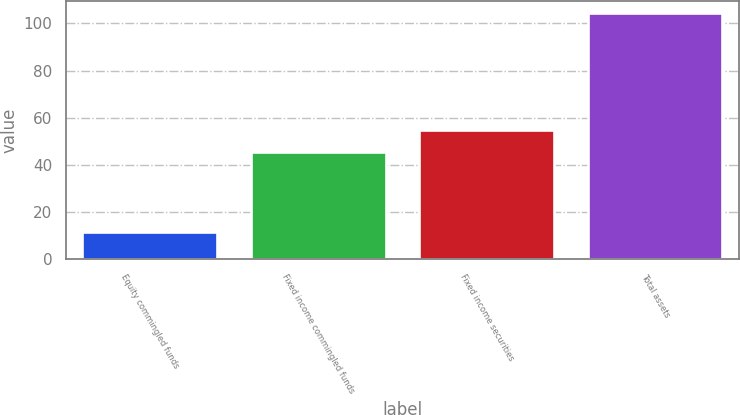<chart> <loc_0><loc_0><loc_500><loc_500><bar_chart><fcel>Equity commingled funds<fcel>Fixed income commingled funds<fcel>Fixed income securities<fcel>Total assets<nl><fcel>11.7<fcel>45.6<fcel>54.87<fcel>104.4<nl></chart> 